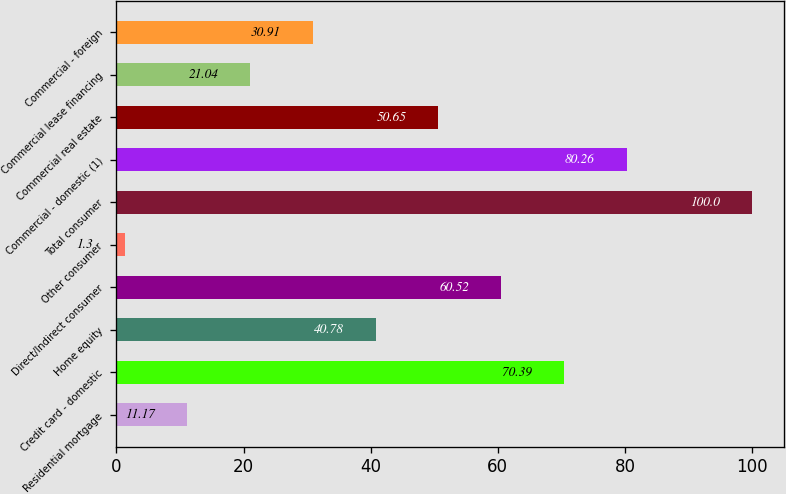<chart> <loc_0><loc_0><loc_500><loc_500><bar_chart><fcel>Residential mortgage<fcel>Credit card - domestic<fcel>Home equity<fcel>Direct/Indirect consumer<fcel>Other consumer<fcel>Total consumer<fcel>Commercial - domestic (1)<fcel>Commercial real estate<fcel>Commercial lease financing<fcel>Commercial - foreign<nl><fcel>11.17<fcel>70.39<fcel>40.78<fcel>60.52<fcel>1.3<fcel>100<fcel>80.26<fcel>50.65<fcel>21.04<fcel>30.91<nl></chart> 